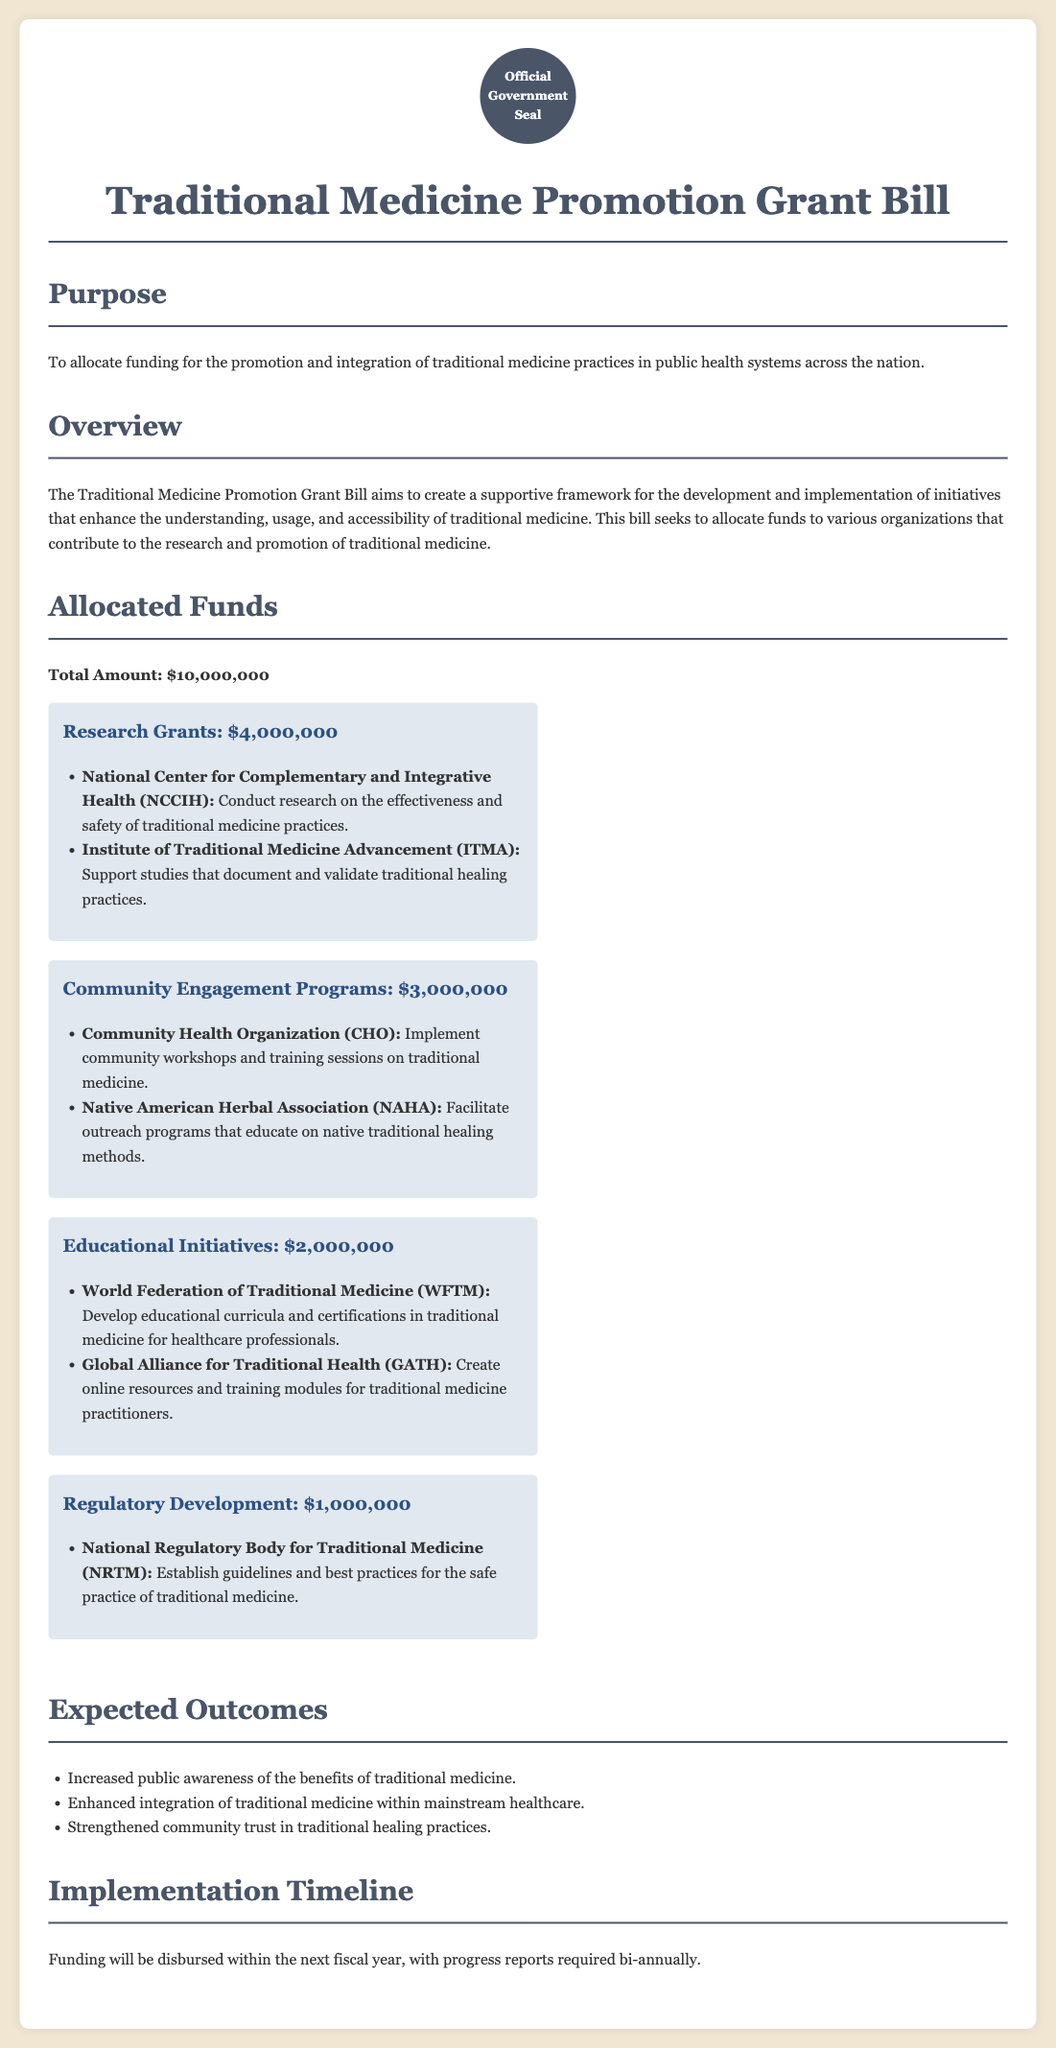What is the total amount allocated for the grant? The total amount allocated for the Traditional Medicine Promotion Grant is specified in the document as $10,000,000.
Answer: $10,000,000 How much funding is allocated for Research Grants? The funding allocated for Research Grants is specifically noted in the document, which states $4,000,000 for this category.
Answer: $4,000,000 Which organization is responsible for establishing guidelines for traditional medicine? The organization listed in the document as responsible for establishing guidelines is the National Regulatory Body for Traditional Medicine (NRTM).
Answer: National Regulatory Body for Traditional Medicine (NRTM) What is one expected outcome of the bill? The document lists multiple expected outcomes, one of which is increased public awareness of the benefits of traditional medicine.
Answer: Increased public awareness of the benefits of traditional medicine How is the funding for Community Engagement Programs divided? The document specifies that the funding allocated for Community Engagement Programs totals $3,000,000 as indicated in the breakdown section.
Answer: $3,000,000 What are the two organizations receiving funding for Educational Initiatives? The document outlines that the organizations receiving funding are the World Federation of Traditional Medicine (WFTM) and the Global Alliance for Traditional Health (GATH).
Answer: World Federation of Traditional Medicine (WFTM) and Global Alliance for Traditional Health (GATH) What is the total funding for Regulatory Development? The document explicitly states that the allocated funding for Regulatory Development is $1,000,000.
Answer: $1,000,000 When will the funding be disbursed? The document notes that funding will be disbursed within the next fiscal year.
Answer: Next fiscal year How often are progress reports required? According to the document, progress reports are required bi-annually.
Answer: Bi-annually 